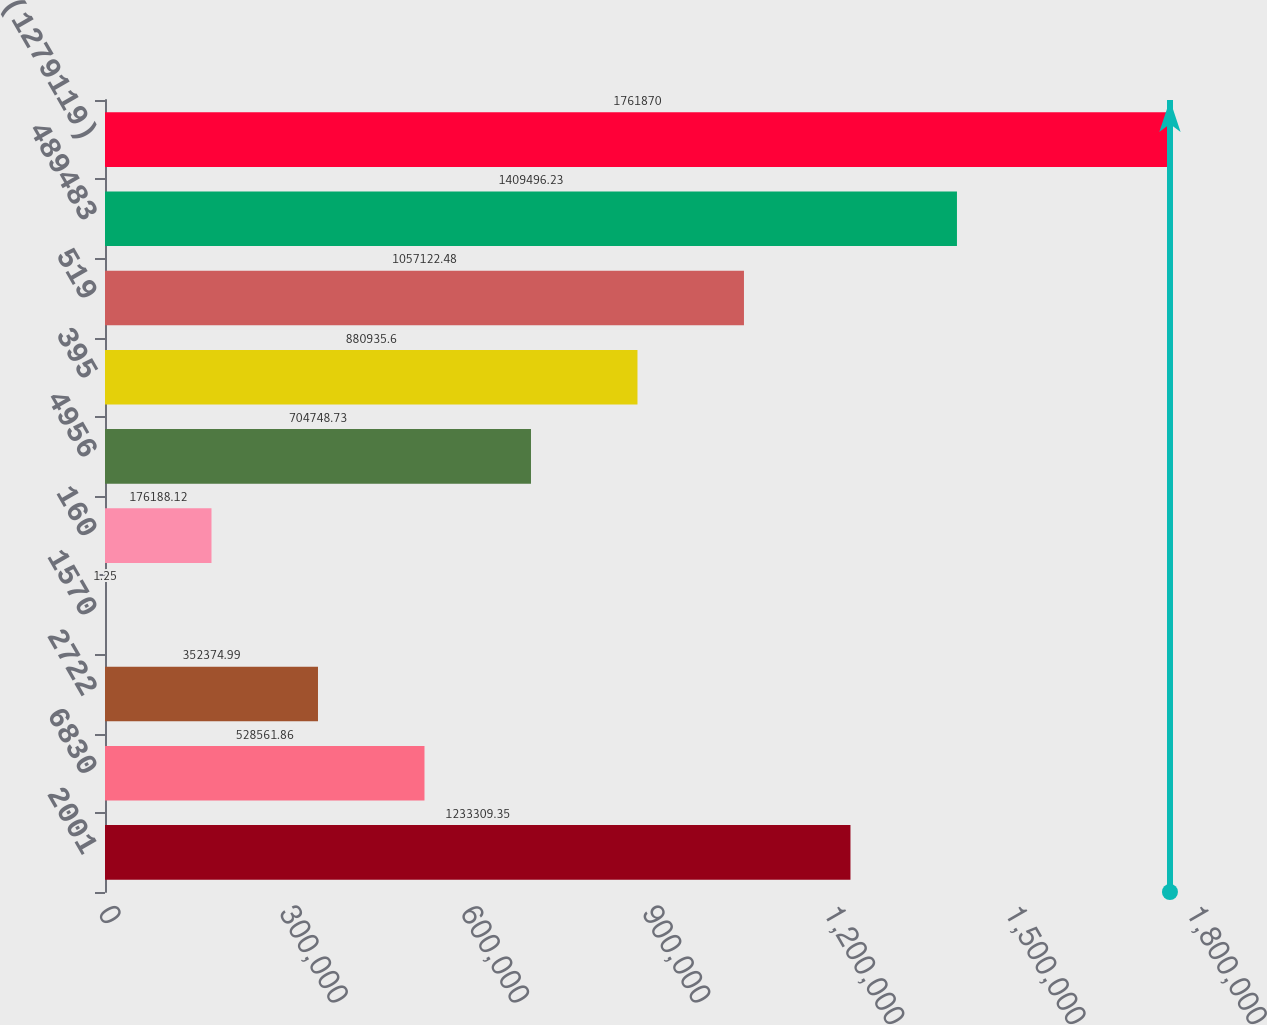Convert chart. <chart><loc_0><loc_0><loc_500><loc_500><bar_chart><fcel>2001<fcel>6830<fcel>2722<fcel>1570<fcel>160<fcel>4956<fcel>395<fcel>519<fcel>489483<fcel>(1279119)<nl><fcel>1.23331e+06<fcel>528562<fcel>352375<fcel>1.25<fcel>176188<fcel>704749<fcel>880936<fcel>1.05712e+06<fcel>1.4095e+06<fcel>1.76187e+06<nl></chart> 